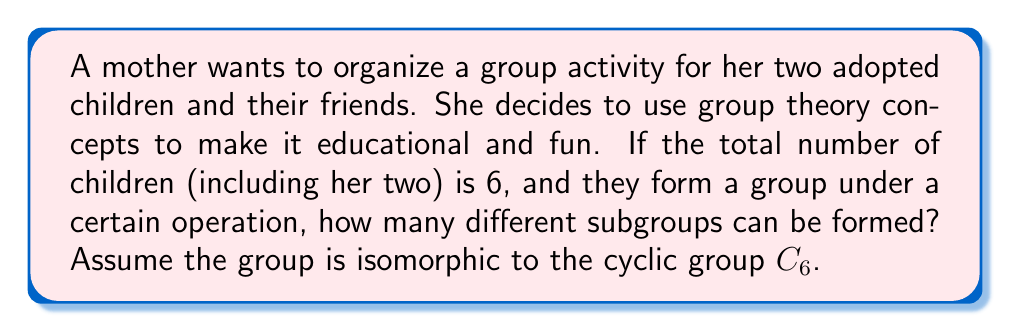Provide a solution to this math problem. To solve this problem, we need to follow these steps:

1) First, recall that $C_6$ is the cyclic group of order 6. It has a generator $a$ such that $C_6 = \{e, a, a^2, a^3, a^4, a^5\}$ where $e$ is the identity element.

2) To find the number of subgroups, we need to consider the divisors of the group order. The divisors of 6 are 1, 2, 3, and 6.

3) For each divisor $d$, there will be a unique subgroup of order $d$:

   - For $d=1$: The trivial subgroup $\{e\}$
   - For $d=2$: The subgroup $\{e, a^3\}$
   - For $d=3$: The subgroup $\{e, a^2, a^4\}$
   - For $d=6$: The entire group $C_6$

4) The total number of subgroups is equal to the number of divisors of the group order.

5) Therefore, the number of subgroups in $C_6$ is equal to the number of divisors of 6, which is 4.

This problem relates to the mother's situation as she can use this concept to divide the children into different sized groups for various activities, demonstrating the practical application of group theory.
Answer: The number of subgroups in $C_6$ is 4. 